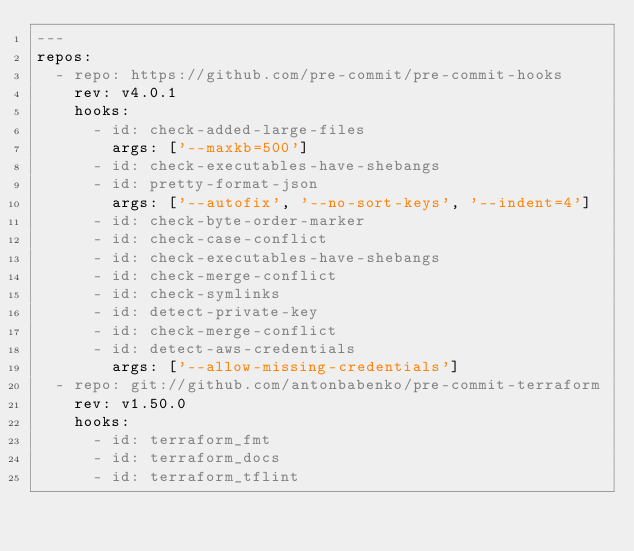<code> <loc_0><loc_0><loc_500><loc_500><_YAML_>---
repos:
  - repo: https://github.com/pre-commit/pre-commit-hooks
    rev: v4.0.1
    hooks:
      - id: check-added-large-files
        args: ['--maxkb=500']
      - id: check-executables-have-shebangs
      - id: pretty-format-json
        args: ['--autofix', '--no-sort-keys', '--indent=4']
      - id: check-byte-order-marker
      - id: check-case-conflict
      - id: check-executables-have-shebangs
      - id: check-merge-conflict
      - id: check-symlinks
      - id: detect-private-key
      - id: check-merge-conflict
      - id: detect-aws-credentials
        args: ['--allow-missing-credentials']
  - repo: git://github.com/antonbabenko/pre-commit-terraform
    rev: v1.50.0
    hooks:
      - id: terraform_fmt
      - id: terraform_docs
      - id: terraform_tflint
</code> 